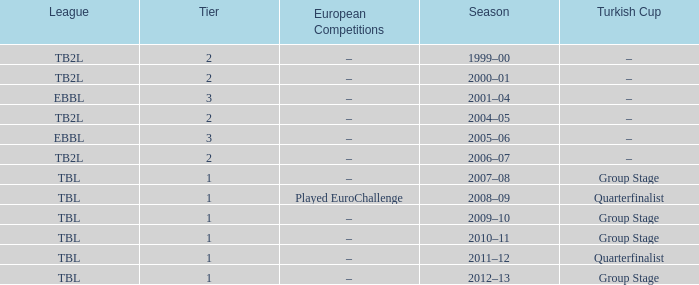Season of 2012–13 is what league? TBL. 